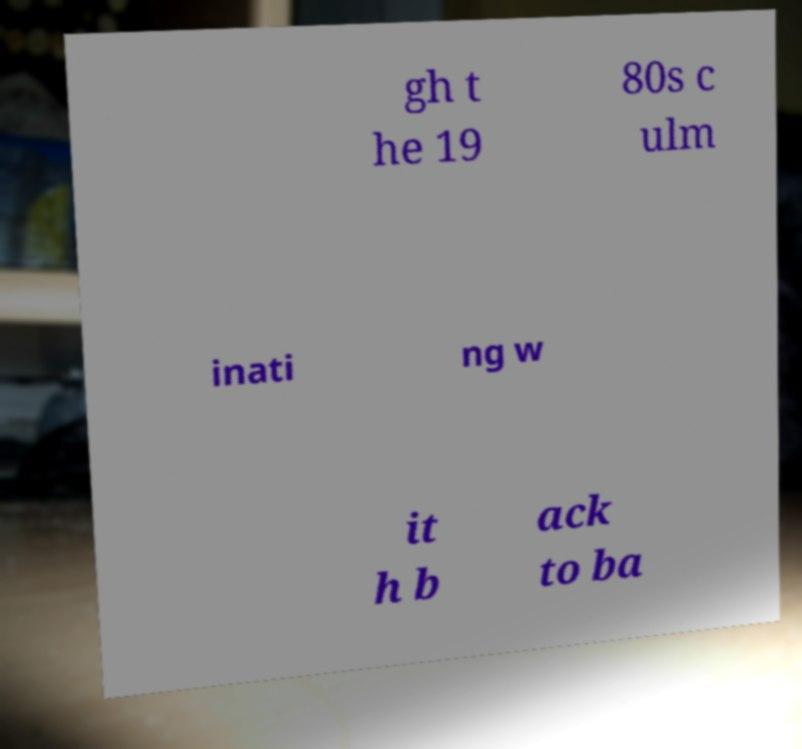Can you accurately transcribe the text from the provided image for me? gh t he 19 80s c ulm inati ng w it h b ack to ba 